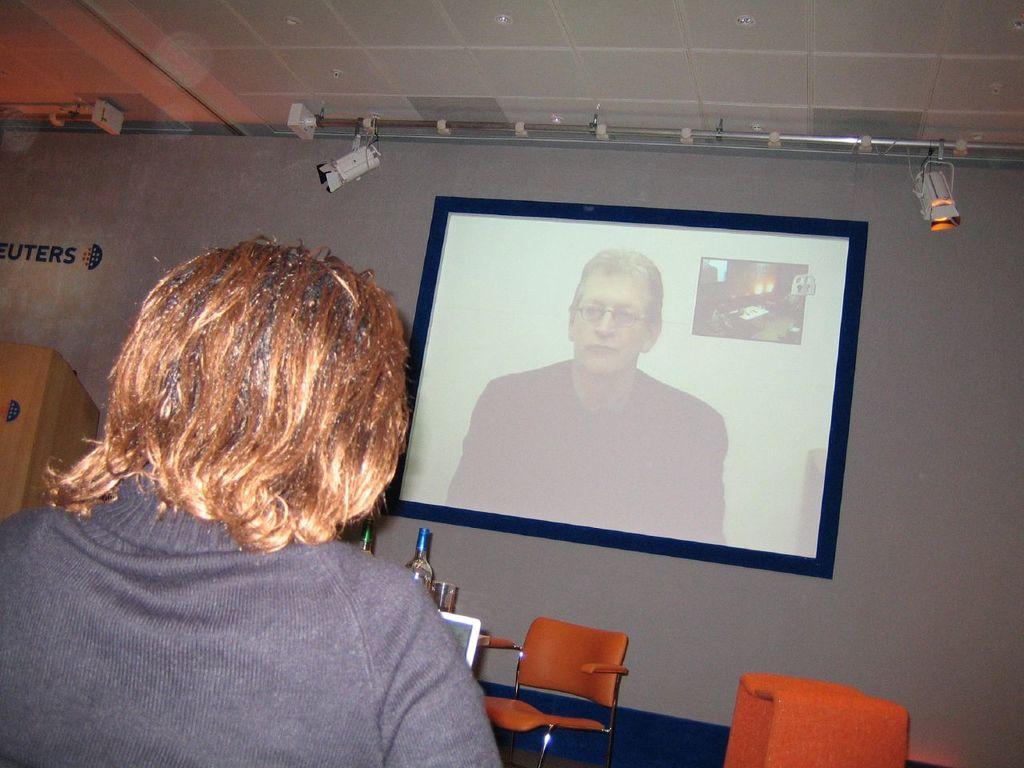Can you describe this image briefly? In this image there is a screen attached to the wall. On the left side there is a person who is looking at this screen. In the background there are two chairs and few bottles. 